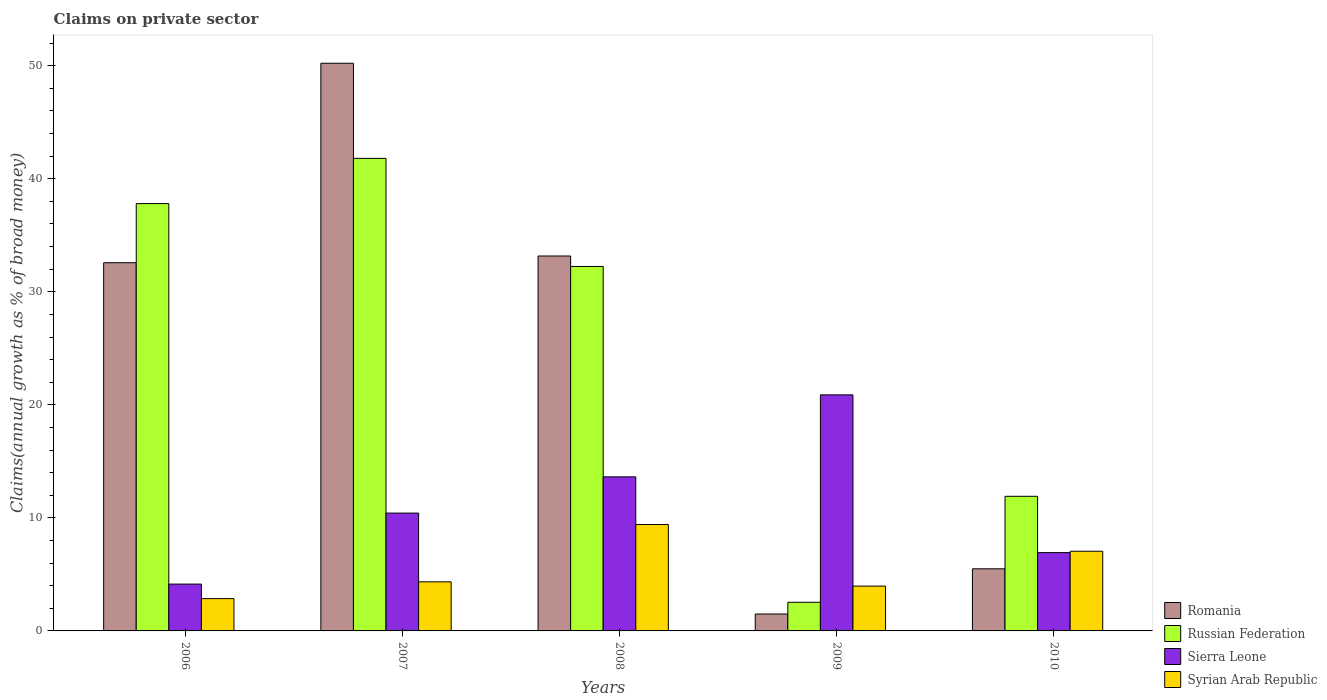How many different coloured bars are there?
Your answer should be compact. 4. How many bars are there on the 3rd tick from the left?
Provide a short and direct response. 4. What is the label of the 3rd group of bars from the left?
Your answer should be compact. 2008. In how many cases, is the number of bars for a given year not equal to the number of legend labels?
Ensure brevity in your answer.  0. What is the percentage of broad money claimed on private sector in Russian Federation in 2009?
Provide a short and direct response. 2.53. Across all years, what is the maximum percentage of broad money claimed on private sector in Sierra Leone?
Make the answer very short. 20.88. Across all years, what is the minimum percentage of broad money claimed on private sector in Sierra Leone?
Make the answer very short. 4.14. What is the total percentage of broad money claimed on private sector in Russian Federation in the graph?
Make the answer very short. 126.29. What is the difference between the percentage of broad money claimed on private sector in Syrian Arab Republic in 2007 and that in 2008?
Your answer should be compact. -5.07. What is the difference between the percentage of broad money claimed on private sector in Syrian Arab Republic in 2008 and the percentage of broad money claimed on private sector in Russian Federation in 2010?
Provide a short and direct response. -2.5. What is the average percentage of broad money claimed on private sector in Syrian Arab Republic per year?
Keep it short and to the point. 5.52. In the year 2007, what is the difference between the percentage of broad money claimed on private sector in Romania and percentage of broad money claimed on private sector in Syrian Arab Republic?
Make the answer very short. 45.88. In how many years, is the percentage of broad money claimed on private sector in Sierra Leone greater than 4 %?
Keep it short and to the point. 5. What is the ratio of the percentage of broad money claimed on private sector in Sierra Leone in 2008 to that in 2010?
Give a very brief answer. 1.97. Is the difference between the percentage of broad money claimed on private sector in Romania in 2008 and 2010 greater than the difference between the percentage of broad money claimed on private sector in Syrian Arab Republic in 2008 and 2010?
Make the answer very short. Yes. What is the difference between the highest and the second highest percentage of broad money claimed on private sector in Sierra Leone?
Your answer should be compact. 7.25. What is the difference between the highest and the lowest percentage of broad money claimed on private sector in Russian Federation?
Make the answer very short. 39.27. In how many years, is the percentage of broad money claimed on private sector in Russian Federation greater than the average percentage of broad money claimed on private sector in Russian Federation taken over all years?
Offer a terse response. 3. What does the 2nd bar from the left in 2006 represents?
Give a very brief answer. Russian Federation. What does the 2nd bar from the right in 2007 represents?
Your answer should be very brief. Sierra Leone. Is it the case that in every year, the sum of the percentage of broad money claimed on private sector in Sierra Leone and percentage of broad money claimed on private sector in Syrian Arab Republic is greater than the percentage of broad money claimed on private sector in Romania?
Give a very brief answer. No. Are all the bars in the graph horizontal?
Your answer should be compact. No. What is the difference between two consecutive major ticks on the Y-axis?
Keep it short and to the point. 10. How are the legend labels stacked?
Make the answer very short. Vertical. What is the title of the graph?
Ensure brevity in your answer.  Claims on private sector. Does "Hungary" appear as one of the legend labels in the graph?
Your response must be concise. No. What is the label or title of the X-axis?
Provide a short and direct response. Years. What is the label or title of the Y-axis?
Provide a succinct answer. Claims(annual growth as % of broad money). What is the Claims(annual growth as % of broad money) in Romania in 2006?
Make the answer very short. 32.57. What is the Claims(annual growth as % of broad money) of Russian Federation in 2006?
Provide a succinct answer. 37.8. What is the Claims(annual growth as % of broad money) in Sierra Leone in 2006?
Your answer should be very brief. 4.14. What is the Claims(annual growth as % of broad money) in Syrian Arab Republic in 2006?
Your answer should be very brief. 2.86. What is the Claims(annual growth as % of broad money) in Romania in 2007?
Provide a succinct answer. 50.22. What is the Claims(annual growth as % of broad money) of Russian Federation in 2007?
Ensure brevity in your answer.  41.8. What is the Claims(annual growth as % of broad money) in Sierra Leone in 2007?
Offer a terse response. 10.42. What is the Claims(annual growth as % of broad money) in Syrian Arab Republic in 2007?
Your response must be concise. 4.34. What is the Claims(annual growth as % of broad money) in Romania in 2008?
Ensure brevity in your answer.  33.17. What is the Claims(annual growth as % of broad money) in Russian Federation in 2008?
Ensure brevity in your answer.  32.24. What is the Claims(annual growth as % of broad money) in Sierra Leone in 2008?
Your response must be concise. 13.63. What is the Claims(annual growth as % of broad money) of Syrian Arab Republic in 2008?
Your response must be concise. 9.41. What is the Claims(annual growth as % of broad money) in Romania in 2009?
Your response must be concise. 1.5. What is the Claims(annual growth as % of broad money) of Russian Federation in 2009?
Ensure brevity in your answer.  2.53. What is the Claims(annual growth as % of broad money) in Sierra Leone in 2009?
Your answer should be compact. 20.88. What is the Claims(annual growth as % of broad money) in Syrian Arab Republic in 2009?
Give a very brief answer. 3.96. What is the Claims(annual growth as % of broad money) in Romania in 2010?
Your response must be concise. 5.49. What is the Claims(annual growth as % of broad money) in Russian Federation in 2010?
Offer a terse response. 11.91. What is the Claims(annual growth as % of broad money) of Sierra Leone in 2010?
Your response must be concise. 6.93. What is the Claims(annual growth as % of broad money) of Syrian Arab Republic in 2010?
Offer a very short reply. 7.05. Across all years, what is the maximum Claims(annual growth as % of broad money) of Romania?
Keep it short and to the point. 50.22. Across all years, what is the maximum Claims(annual growth as % of broad money) of Russian Federation?
Give a very brief answer. 41.8. Across all years, what is the maximum Claims(annual growth as % of broad money) in Sierra Leone?
Provide a succinct answer. 20.88. Across all years, what is the maximum Claims(annual growth as % of broad money) in Syrian Arab Republic?
Provide a succinct answer. 9.41. Across all years, what is the minimum Claims(annual growth as % of broad money) in Romania?
Offer a terse response. 1.5. Across all years, what is the minimum Claims(annual growth as % of broad money) in Russian Federation?
Give a very brief answer. 2.53. Across all years, what is the minimum Claims(annual growth as % of broad money) of Sierra Leone?
Your response must be concise. 4.14. Across all years, what is the minimum Claims(annual growth as % of broad money) of Syrian Arab Republic?
Ensure brevity in your answer.  2.86. What is the total Claims(annual growth as % of broad money) of Romania in the graph?
Your answer should be compact. 122.95. What is the total Claims(annual growth as % of broad money) of Russian Federation in the graph?
Give a very brief answer. 126.29. What is the total Claims(annual growth as % of broad money) of Sierra Leone in the graph?
Give a very brief answer. 56.01. What is the total Claims(annual growth as % of broad money) of Syrian Arab Republic in the graph?
Ensure brevity in your answer.  27.62. What is the difference between the Claims(annual growth as % of broad money) in Romania in 2006 and that in 2007?
Your response must be concise. -17.65. What is the difference between the Claims(annual growth as % of broad money) in Russian Federation in 2006 and that in 2007?
Give a very brief answer. -4. What is the difference between the Claims(annual growth as % of broad money) in Sierra Leone in 2006 and that in 2007?
Your answer should be compact. -6.28. What is the difference between the Claims(annual growth as % of broad money) in Syrian Arab Republic in 2006 and that in 2007?
Offer a very short reply. -1.48. What is the difference between the Claims(annual growth as % of broad money) in Romania in 2006 and that in 2008?
Your answer should be compact. -0.6. What is the difference between the Claims(annual growth as % of broad money) of Russian Federation in 2006 and that in 2008?
Your answer should be very brief. 5.56. What is the difference between the Claims(annual growth as % of broad money) in Sierra Leone in 2006 and that in 2008?
Offer a terse response. -9.49. What is the difference between the Claims(annual growth as % of broad money) of Syrian Arab Republic in 2006 and that in 2008?
Ensure brevity in your answer.  -6.55. What is the difference between the Claims(annual growth as % of broad money) of Romania in 2006 and that in 2009?
Ensure brevity in your answer.  31.08. What is the difference between the Claims(annual growth as % of broad money) of Russian Federation in 2006 and that in 2009?
Ensure brevity in your answer.  35.27. What is the difference between the Claims(annual growth as % of broad money) in Sierra Leone in 2006 and that in 2009?
Provide a short and direct response. -16.74. What is the difference between the Claims(annual growth as % of broad money) of Syrian Arab Republic in 2006 and that in 2009?
Ensure brevity in your answer.  -1.11. What is the difference between the Claims(annual growth as % of broad money) of Romania in 2006 and that in 2010?
Your answer should be compact. 27.08. What is the difference between the Claims(annual growth as % of broad money) of Russian Federation in 2006 and that in 2010?
Offer a very short reply. 25.89. What is the difference between the Claims(annual growth as % of broad money) of Sierra Leone in 2006 and that in 2010?
Make the answer very short. -2.78. What is the difference between the Claims(annual growth as % of broad money) of Syrian Arab Republic in 2006 and that in 2010?
Offer a very short reply. -4.19. What is the difference between the Claims(annual growth as % of broad money) in Romania in 2007 and that in 2008?
Your response must be concise. 17.05. What is the difference between the Claims(annual growth as % of broad money) in Russian Federation in 2007 and that in 2008?
Make the answer very short. 9.56. What is the difference between the Claims(annual growth as % of broad money) in Sierra Leone in 2007 and that in 2008?
Keep it short and to the point. -3.21. What is the difference between the Claims(annual growth as % of broad money) of Syrian Arab Republic in 2007 and that in 2008?
Your answer should be compact. -5.07. What is the difference between the Claims(annual growth as % of broad money) of Romania in 2007 and that in 2009?
Give a very brief answer. 48.72. What is the difference between the Claims(annual growth as % of broad money) of Russian Federation in 2007 and that in 2009?
Ensure brevity in your answer.  39.27. What is the difference between the Claims(annual growth as % of broad money) in Sierra Leone in 2007 and that in 2009?
Provide a short and direct response. -10.46. What is the difference between the Claims(annual growth as % of broad money) of Syrian Arab Republic in 2007 and that in 2009?
Your answer should be compact. 0.38. What is the difference between the Claims(annual growth as % of broad money) in Romania in 2007 and that in 2010?
Provide a short and direct response. 44.72. What is the difference between the Claims(annual growth as % of broad money) in Russian Federation in 2007 and that in 2010?
Ensure brevity in your answer.  29.89. What is the difference between the Claims(annual growth as % of broad money) in Sierra Leone in 2007 and that in 2010?
Your response must be concise. 3.5. What is the difference between the Claims(annual growth as % of broad money) in Syrian Arab Republic in 2007 and that in 2010?
Your response must be concise. -2.71. What is the difference between the Claims(annual growth as % of broad money) in Romania in 2008 and that in 2009?
Offer a terse response. 31.67. What is the difference between the Claims(annual growth as % of broad money) in Russian Federation in 2008 and that in 2009?
Give a very brief answer. 29.71. What is the difference between the Claims(annual growth as % of broad money) of Sierra Leone in 2008 and that in 2009?
Give a very brief answer. -7.25. What is the difference between the Claims(annual growth as % of broad money) of Syrian Arab Republic in 2008 and that in 2009?
Keep it short and to the point. 5.45. What is the difference between the Claims(annual growth as % of broad money) of Romania in 2008 and that in 2010?
Provide a succinct answer. 27.67. What is the difference between the Claims(annual growth as % of broad money) in Russian Federation in 2008 and that in 2010?
Your answer should be very brief. 20.33. What is the difference between the Claims(annual growth as % of broad money) of Sierra Leone in 2008 and that in 2010?
Provide a short and direct response. 6.7. What is the difference between the Claims(annual growth as % of broad money) in Syrian Arab Republic in 2008 and that in 2010?
Provide a succinct answer. 2.36. What is the difference between the Claims(annual growth as % of broad money) of Romania in 2009 and that in 2010?
Offer a terse response. -4. What is the difference between the Claims(annual growth as % of broad money) of Russian Federation in 2009 and that in 2010?
Your answer should be very brief. -9.38. What is the difference between the Claims(annual growth as % of broad money) in Sierra Leone in 2009 and that in 2010?
Your answer should be very brief. 13.96. What is the difference between the Claims(annual growth as % of broad money) of Syrian Arab Republic in 2009 and that in 2010?
Make the answer very short. -3.08. What is the difference between the Claims(annual growth as % of broad money) in Romania in 2006 and the Claims(annual growth as % of broad money) in Russian Federation in 2007?
Your answer should be compact. -9.23. What is the difference between the Claims(annual growth as % of broad money) of Romania in 2006 and the Claims(annual growth as % of broad money) of Sierra Leone in 2007?
Make the answer very short. 22.15. What is the difference between the Claims(annual growth as % of broad money) of Romania in 2006 and the Claims(annual growth as % of broad money) of Syrian Arab Republic in 2007?
Make the answer very short. 28.23. What is the difference between the Claims(annual growth as % of broad money) of Russian Federation in 2006 and the Claims(annual growth as % of broad money) of Sierra Leone in 2007?
Make the answer very short. 27.38. What is the difference between the Claims(annual growth as % of broad money) in Russian Federation in 2006 and the Claims(annual growth as % of broad money) in Syrian Arab Republic in 2007?
Your response must be concise. 33.46. What is the difference between the Claims(annual growth as % of broad money) of Sierra Leone in 2006 and the Claims(annual growth as % of broad money) of Syrian Arab Republic in 2007?
Offer a terse response. -0.2. What is the difference between the Claims(annual growth as % of broad money) in Romania in 2006 and the Claims(annual growth as % of broad money) in Russian Federation in 2008?
Offer a terse response. 0.33. What is the difference between the Claims(annual growth as % of broad money) in Romania in 2006 and the Claims(annual growth as % of broad money) in Sierra Leone in 2008?
Offer a terse response. 18.94. What is the difference between the Claims(annual growth as % of broad money) of Romania in 2006 and the Claims(annual growth as % of broad money) of Syrian Arab Republic in 2008?
Offer a terse response. 23.16. What is the difference between the Claims(annual growth as % of broad money) in Russian Federation in 2006 and the Claims(annual growth as % of broad money) in Sierra Leone in 2008?
Keep it short and to the point. 24.17. What is the difference between the Claims(annual growth as % of broad money) of Russian Federation in 2006 and the Claims(annual growth as % of broad money) of Syrian Arab Republic in 2008?
Give a very brief answer. 28.39. What is the difference between the Claims(annual growth as % of broad money) of Sierra Leone in 2006 and the Claims(annual growth as % of broad money) of Syrian Arab Republic in 2008?
Give a very brief answer. -5.27. What is the difference between the Claims(annual growth as % of broad money) of Romania in 2006 and the Claims(annual growth as % of broad money) of Russian Federation in 2009?
Your response must be concise. 30.04. What is the difference between the Claims(annual growth as % of broad money) of Romania in 2006 and the Claims(annual growth as % of broad money) of Sierra Leone in 2009?
Your answer should be compact. 11.69. What is the difference between the Claims(annual growth as % of broad money) in Romania in 2006 and the Claims(annual growth as % of broad money) in Syrian Arab Republic in 2009?
Your answer should be compact. 28.61. What is the difference between the Claims(annual growth as % of broad money) of Russian Federation in 2006 and the Claims(annual growth as % of broad money) of Sierra Leone in 2009?
Provide a short and direct response. 16.92. What is the difference between the Claims(annual growth as % of broad money) in Russian Federation in 2006 and the Claims(annual growth as % of broad money) in Syrian Arab Republic in 2009?
Offer a terse response. 33.84. What is the difference between the Claims(annual growth as % of broad money) of Sierra Leone in 2006 and the Claims(annual growth as % of broad money) of Syrian Arab Republic in 2009?
Your response must be concise. 0.18. What is the difference between the Claims(annual growth as % of broad money) in Romania in 2006 and the Claims(annual growth as % of broad money) in Russian Federation in 2010?
Keep it short and to the point. 20.66. What is the difference between the Claims(annual growth as % of broad money) in Romania in 2006 and the Claims(annual growth as % of broad money) in Sierra Leone in 2010?
Provide a short and direct response. 25.64. What is the difference between the Claims(annual growth as % of broad money) in Romania in 2006 and the Claims(annual growth as % of broad money) in Syrian Arab Republic in 2010?
Provide a succinct answer. 25.52. What is the difference between the Claims(annual growth as % of broad money) of Russian Federation in 2006 and the Claims(annual growth as % of broad money) of Sierra Leone in 2010?
Make the answer very short. 30.88. What is the difference between the Claims(annual growth as % of broad money) of Russian Federation in 2006 and the Claims(annual growth as % of broad money) of Syrian Arab Republic in 2010?
Make the answer very short. 30.75. What is the difference between the Claims(annual growth as % of broad money) of Sierra Leone in 2006 and the Claims(annual growth as % of broad money) of Syrian Arab Republic in 2010?
Provide a succinct answer. -2.9. What is the difference between the Claims(annual growth as % of broad money) in Romania in 2007 and the Claims(annual growth as % of broad money) in Russian Federation in 2008?
Offer a very short reply. 17.98. What is the difference between the Claims(annual growth as % of broad money) in Romania in 2007 and the Claims(annual growth as % of broad money) in Sierra Leone in 2008?
Provide a succinct answer. 36.59. What is the difference between the Claims(annual growth as % of broad money) of Romania in 2007 and the Claims(annual growth as % of broad money) of Syrian Arab Republic in 2008?
Your answer should be very brief. 40.81. What is the difference between the Claims(annual growth as % of broad money) in Russian Federation in 2007 and the Claims(annual growth as % of broad money) in Sierra Leone in 2008?
Your answer should be compact. 28.17. What is the difference between the Claims(annual growth as % of broad money) in Russian Federation in 2007 and the Claims(annual growth as % of broad money) in Syrian Arab Republic in 2008?
Ensure brevity in your answer.  32.39. What is the difference between the Claims(annual growth as % of broad money) of Sierra Leone in 2007 and the Claims(annual growth as % of broad money) of Syrian Arab Republic in 2008?
Give a very brief answer. 1.01. What is the difference between the Claims(annual growth as % of broad money) in Romania in 2007 and the Claims(annual growth as % of broad money) in Russian Federation in 2009?
Your answer should be compact. 47.69. What is the difference between the Claims(annual growth as % of broad money) in Romania in 2007 and the Claims(annual growth as % of broad money) in Sierra Leone in 2009?
Provide a short and direct response. 29.33. What is the difference between the Claims(annual growth as % of broad money) of Romania in 2007 and the Claims(annual growth as % of broad money) of Syrian Arab Republic in 2009?
Your answer should be compact. 46.25. What is the difference between the Claims(annual growth as % of broad money) of Russian Federation in 2007 and the Claims(annual growth as % of broad money) of Sierra Leone in 2009?
Provide a short and direct response. 20.92. What is the difference between the Claims(annual growth as % of broad money) in Russian Federation in 2007 and the Claims(annual growth as % of broad money) in Syrian Arab Republic in 2009?
Your answer should be very brief. 37.84. What is the difference between the Claims(annual growth as % of broad money) of Sierra Leone in 2007 and the Claims(annual growth as % of broad money) of Syrian Arab Republic in 2009?
Give a very brief answer. 6.46. What is the difference between the Claims(annual growth as % of broad money) in Romania in 2007 and the Claims(annual growth as % of broad money) in Russian Federation in 2010?
Your response must be concise. 38.31. What is the difference between the Claims(annual growth as % of broad money) in Romania in 2007 and the Claims(annual growth as % of broad money) in Sierra Leone in 2010?
Make the answer very short. 43.29. What is the difference between the Claims(annual growth as % of broad money) in Romania in 2007 and the Claims(annual growth as % of broad money) in Syrian Arab Republic in 2010?
Ensure brevity in your answer.  43.17. What is the difference between the Claims(annual growth as % of broad money) in Russian Federation in 2007 and the Claims(annual growth as % of broad money) in Sierra Leone in 2010?
Keep it short and to the point. 34.88. What is the difference between the Claims(annual growth as % of broad money) in Russian Federation in 2007 and the Claims(annual growth as % of broad money) in Syrian Arab Republic in 2010?
Ensure brevity in your answer.  34.76. What is the difference between the Claims(annual growth as % of broad money) of Sierra Leone in 2007 and the Claims(annual growth as % of broad money) of Syrian Arab Republic in 2010?
Offer a very short reply. 3.38. What is the difference between the Claims(annual growth as % of broad money) in Romania in 2008 and the Claims(annual growth as % of broad money) in Russian Federation in 2009?
Provide a short and direct response. 30.64. What is the difference between the Claims(annual growth as % of broad money) in Romania in 2008 and the Claims(annual growth as % of broad money) in Sierra Leone in 2009?
Your answer should be very brief. 12.28. What is the difference between the Claims(annual growth as % of broad money) of Romania in 2008 and the Claims(annual growth as % of broad money) of Syrian Arab Republic in 2009?
Your answer should be compact. 29.2. What is the difference between the Claims(annual growth as % of broad money) of Russian Federation in 2008 and the Claims(annual growth as % of broad money) of Sierra Leone in 2009?
Keep it short and to the point. 11.36. What is the difference between the Claims(annual growth as % of broad money) of Russian Federation in 2008 and the Claims(annual growth as % of broad money) of Syrian Arab Republic in 2009?
Offer a very short reply. 28.28. What is the difference between the Claims(annual growth as % of broad money) of Sierra Leone in 2008 and the Claims(annual growth as % of broad money) of Syrian Arab Republic in 2009?
Keep it short and to the point. 9.67. What is the difference between the Claims(annual growth as % of broad money) of Romania in 2008 and the Claims(annual growth as % of broad money) of Russian Federation in 2010?
Provide a short and direct response. 21.26. What is the difference between the Claims(annual growth as % of broad money) of Romania in 2008 and the Claims(annual growth as % of broad money) of Sierra Leone in 2010?
Make the answer very short. 26.24. What is the difference between the Claims(annual growth as % of broad money) in Romania in 2008 and the Claims(annual growth as % of broad money) in Syrian Arab Republic in 2010?
Provide a short and direct response. 26.12. What is the difference between the Claims(annual growth as % of broad money) in Russian Federation in 2008 and the Claims(annual growth as % of broad money) in Sierra Leone in 2010?
Make the answer very short. 25.31. What is the difference between the Claims(annual growth as % of broad money) in Russian Federation in 2008 and the Claims(annual growth as % of broad money) in Syrian Arab Republic in 2010?
Make the answer very short. 25.19. What is the difference between the Claims(annual growth as % of broad money) of Sierra Leone in 2008 and the Claims(annual growth as % of broad money) of Syrian Arab Republic in 2010?
Your response must be concise. 6.58. What is the difference between the Claims(annual growth as % of broad money) in Romania in 2009 and the Claims(annual growth as % of broad money) in Russian Federation in 2010?
Provide a short and direct response. -10.41. What is the difference between the Claims(annual growth as % of broad money) in Romania in 2009 and the Claims(annual growth as % of broad money) in Sierra Leone in 2010?
Give a very brief answer. -5.43. What is the difference between the Claims(annual growth as % of broad money) of Romania in 2009 and the Claims(annual growth as % of broad money) of Syrian Arab Republic in 2010?
Keep it short and to the point. -5.55. What is the difference between the Claims(annual growth as % of broad money) of Russian Federation in 2009 and the Claims(annual growth as % of broad money) of Sierra Leone in 2010?
Provide a short and direct response. -4.39. What is the difference between the Claims(annual growth as % of broad money) in Russian Federation in 2009 and the Claims(annual growth as % of broad money) in Syrian Arab Republic in 2010?
Your answer should be very brief. -4.52. What is the difference between the Claims(annual growth as % of broad money) of Sierra Leone in 2009 and the Claims(annual growth as % of broad money) of Syrian Arab Republic in 2010?
Offer a terse response. 13.84. What is the average Claims(annual growth as % of broad money) of Romania per year?
Your answer should be compact. 24.59. What is the average Claims(annual growth as % of broad money) of Russian Federation per year?
Keep it short and to the point. 25.26. What is the average Claims(annual growth as % of broad money) of Sierra Leone per year?
Give a very brief answer. 11.2. What is the average Claims(annual growth as % of broad money) of Syrian Arab Republic per year?
Offer a very short reply. 5.52. In the year 2006, what is the difference between the Claims(annual growth as % of broad money) in Romania and Claims(annual growth as % of broad money) in Russian Federation?
Provide a succinct answer. -5.23. In the year 2006, what is the difference between the Claims(annual growth as % of broad money) in Romania and Claims(annual growth as % of broad money) in Sierra Leone?
Offer a terse response. 28.43. In the year 2006, what is the difference between the Claims(annual growth as % of broad money) in Romania and Claims(annual growth as % of broad money) in Syrian Arab Republic?
Offer a very short reply. 29.72. In the year 2006, what is the difference between the Claims(annual growth as % of broad money) in Russian Federation and Claims(annual growth as % of broad money) in Sierra Leone?
Make the answer very short. 33.66. In the year 2006, what is the difference between the Claims(annual growth as % of broad money) of Russian Federation and Claims(annual growth as % of broad money) of Syrian Arab Republic?
Your answer should be very brief. 34.95. In the year 2006, what is the difference between the Claims(annual growth as % of broad money) of Sierra Leone and Claims(annual growth as % of broad money) of Syrian Arab Republic?
Keep it short and to the point. 1.29. In the year 2007, what is the difference between the Claims(annual growth as % of broad money) of Romania and Claims(annual growth as % of broad money) of Russian Federation?
Ensure brevity in your answer.  8.42. In the year 2007, what is the difference between the Claims(annual growth as % of broad money) in Romania and Claims(annual growth as % of broad money) in Sierra Leone?
Provide a short and direct response. 39.8. In the year 2007, what is the difference between the Claims(annual growth as % of broad money) in Romania and Claims(annual growth as % of broad money) in Syrian Arab Republic?
Your response must be concise. 45.88. In the year 2007, what is the difference between the Claims(annual growth as % of broad money) of Russian Federation and Claims(annual growth as % of broad money) of Sierra Leone?
Ensure brevity in your answer.  31.38. In the year 2007, what is the difference between the Claims(annual growth as % of broad money) of Russian Federation and Claims(annual growth as % of broad money) of Syrian Arab Republic?
Give a very brief answer. 37.46. In the year 2007, what is the difference between the Claims(annual growth as % of broad money) of Sierra Leone and Claims(annual growth as % of broad money) of Syrian Arab Republic?
Keep it short and to the point. 6.08. In the year 2008, what is the difference between the Claims(annual growth as % of broad money) in Romania and Claims(annual growth as % of broad money) in Russian Federation?
Your response must be concise. 0.93. In the year 2008, what is the difference between the Claims(annual growth as % of broad money) in Romania and Claims(annual growth as % of broad money) in Sierra Leone?
Your response must be concise. 19.54. In the year 2008, what is the difference between the Claims(annual growth as % of broad money) in Romania and Claims(annual growth as % of broad money) in Syrian Arab Republic?
Make the answer very short. 23.76. In the year 2008, what is the difference between the Claims(annual growth as % of broad money) of Russian Federation and Claims(annual growth as % of broad money) of Sierra Leone?
Your answer should be very brief. 18.61. In the year 2008, what is the difference between the Claims(annual growth as % of broad money) of Russian Federation and Claims(annual growth as % of broad money) of Syrian Arab Republic?
Your answer should be compact. 22.83. In the year 2008, what is the difference between the Claims(annual growth as % of broad money) in Sierra Leone and Claims(annual growth as % of broad money) in Syrian Arab Republic?
Make the answer very short. 4.22. In the year 2009, what is the difference between the Claims(annual growth as % of broad money) in Romania and Claims(annual growth as % of broad money) in Russian Federation?
Offer a terse response. -1.04. In the year 2009, what is the difference between the Claims(annual growth as % of broad money) in Romania and Claims(annual growth as % of broad money) in Sierra Leone?
Provide a short and direct response. -19.39. In the year 2009, what is the difference between the Claims(annual growth as % of broad money) of Romania and Claims(annual growth as % of broad money) of Syrian Arab Republic?
Ensure brevity in your answer.  -2.47. In the year 2009, what is the difference between the Claims(annual growth as % of broad money) of Russian Federation and Claims(annual growth as % of broad money) of Sierra Leone?
Your answer should be very brief. -18.35. In the year 2009, what is the difference between the Claims(annual growth as % of broad money) of Russian Federation and Claims(annual growth as % of broad money) of Syrian Arab Republic?
Your answer should be compact. -1.43. In the year 2009, what is the difference between the Claims(annual growth as % of broad money) of Sierra Leone and Claims(annual growth as % of broad money) of Syrian Arab Republic?
Make the answer very short. 16.92. In the year 2010, what is the difference between the Claims(annual growth as % of broad money) in Romania and Claims(annual growth as % of broad money) in Russian Federation?
Provide a short and direct response. -6.41. In the year 2010, what is the difference between the Claims(annual growth as % of broad money) of Romania and Claims(annual growth as % of broad money) of Sierra Leone?
Your answer should be very brief. -1.43. In the year 2010, what is the difference between the Claims(annual growth as % of broad money) in Romania and Claims(annual growth as % of broad money) in Syrian Arab Republic?
Your response must be concise. -1.55. In the year 2010, what is the difference between the Claims(annual growth as % of broad money) in Russian Federation and Claims(annual growth as % of broad money) in Sierra Leone?
Give a very brief answer. 4.98. In the year 2010, what is the difference between the Claims(annual growth as % of broad money) of Russian Federation and Claims(annual growth as % of broad money) of Syrian Arab Republic?
Provide a succinct answer. 4.86. In the year 2010, what is the difference between the Claims(annual growth as % of broad money) in Sierra Leone and Claims(annual growth as % of broad money) in Syrian Arab Republic?
Provide a succinct answer. -0.12. What is the ratio of the Claims(annual growth as % of broad money) in Romania in 2006 to that in 2007?
Your answer should be very brief. 0.65. What is the ratio of the Claims(annual growth as % of broad money) in Russian Federation in 2006 to that in 2007?
Offer a very short reply. 0.9. What is the ratio of the Claims(annual growth as % of broad money) in Sierra Leone in 2006 to that in 2007?
Offer a terse response. 0.4. What is the ratio of the Claims(annual growth as % of broad money) of Syrian Arab Republic in 2006 to that in 2007?
Your answer should be compact. 0.66. What is the ratio of the Claims(annual growth as % of broad money) in Russian Federation in 2006 to that in 2008?
Ensure brevity in your answer.  1.17. What is the ratio of the Claims(annual growth as % of broad money) in Sierra Leone in 2006 to that in 2008?
Give a very brief answer. 0.3. What is the ratio of the Claims(annual growth as % of broad money) of Syrian Arab Republic in 2006 to that in 2008?
Keep it short and to the point. 0.3. What is the ratio of the Claims(annual growth as % of broad money) in Romania in 2006 to that in 2009?
Offer a terse response. 21.76. What is the ratio of the Claims(annual growth as % of broad money) in Russian Federation in 2006 to that in 2009?
Ensure brevity in your answer.  14.92. What is the ratio of the Claims(annual growth as % of broad money) of Sierra Leone in 2006 to that in 2009?
Your answer should be very brief. 0.2. What is the ratio of the Claims(annual growth as % of broad money) of Syrian Arab Republic in 2006 to that in 2009?
Give a very brief answer. 0.72. What is the ratio of the Claims(annual growth as % of broad money) in Romania in 2006 to that in 2010?
Offer a very short reply. 5.93. What is the ratio of the Claims(annual growth as % of broad money) in Russian Federation in 2006 to that in 2010?
Your answer should be very brief. 3.17. What is the ratio of the Claims(annual growth as % of broad money) of Sierra Leone in 2006 to that in 2010?
Your answer should be very brief. 0.6. What is the ratio of the Claims(annual growth as % of broad money) of Syrian Arab Republic in 2006 to that in 2010?
Offer a very short reply. 0.41. What is the ratio of the Claims(annual growth as % of broad money) in Romania in 2007 to that in 2008?
Offer a very short reply. 1.51. What is the ratio of the Claims(annual growth as % of broad money) of Russian Federation in 2007 to that in 2008?
Ensure brevity in your answer.  1.3. What is the ratio of the Claims(annual growth as % of broad money) of Sierra Leone in 2007 to that in 2008?
Ensure brevity in your answer.  0.76. What is the ratio of the Claims(annual growth as % of broad money) of Syrian Arab Republic in 2007 to that in 2008?
Ensure brevity in your answer.  0.46. What is the ratio of the Claims(annual growth as % of broad money) in Romania in 2007 to that in 2009?
Ensure brevity in your answer.  33.55. What is the ratio of the Claims(annual growth as % of broad money) of Russian Federation in 2007 to that in 2009?
Make the answer very short. 16.5. What is the ratio of the Claims(annual growth as % of broad money) in Sierra Leone in 2007 to that in 2009?
Provide a succinct answer. 0.5. What is the ratio of the Claims(annual growth as % of broad money) of Syrian Arab Republic in 2007 to that in 2009?
Your answer should be compact. 1.1. What is the ratio of the Claims(annual growth as % of broad money) in Romania in 2007 to that in 2010?
Provide a short and direct response. 9.14. What is the ratio of the Claims(annual growth as % of broad money) in Russian Federation in 2007 to that in 2010?
Provide a short and direct response. 3.51. What is the ratio of the Claims(annual growth as % of broad money) of Sierra Leone in 2007 to that in 2010?
Make the answer very short. 1.5. What is the ratio of the Claims(annual growth as % of broad money) of Syrian Arab Republic in 2007 to that in 2010?
Your response must be concise. 0.62. What is the ratio of the Claims(annual growth as % of broad money) in Romania in 2008 to that in 2009?
Offer a terse response. 22.16. What is the ratio of the Claims(annual growth as % of broad money) of Russian Federation in 2008 to that in 2009?
Offer a very short reply. 12.73. What is the ratio of the Claims(annual growth as % of broad money) of Sierra Leone in 2008 to that in 2009?
Make the answer very short. 0.65. What is the ratio of the Claims(annual growth as % of broad money) of Syrian Arab Republic in 2008 to that in 2009?
Make the answer very short. 2.37. What is the ratio of the Claims(annual growth as % of broad money) of Romania in 2008 to that in 2010?
Give a very brief answer. 6.04. What is the ratio of the Claims(annual growth as % of broad money) in Russian Federation in 2008 to that in 2010?
Provide a succinct answer. 2.71. What is the ratio of the Claims(annual growth as % of broad money) of Sierra Leone in 2008 to that in 2010?
Give a very brief answer. 1.97. What is the ratio of the Claims(annual growth as % of broad money) of Syrian Arab Republic in 2008 to that in 2010?
Ensure brevity in your answer.  1.34. What is the ratio of the Claims(annual growth as % of broad money) in Romania in 2009 to that in 2010?
Your response must be concise. 0.27. What is the ratio of the Claims(annual growth as % of broad money) of Russian Federation in 2009 to that in 2010?
Ensure brevity in your answer.  0.21. What is the ratio of the Claims(annual growth as % of broad money) of Sierra Leone in 2009 to that in 2010?
Provide a short and direct response. 3.01. What is the ratio of the Claims(annual growth as % of broad money) in Syrian Arab Republic in 2009 to that in 2010?
Your response must be concise. 0.56. What is the difference between the highest and the second highest Claims(annual growth as % of broad money) in Romania?
Your answer should be very brief. 17.05. What is the difference between the highest and the second highest Claims(annual growth as % of broad money) of Russian Federation?
Keep it short and to the point. 4. What is the difference between the highest and the second highest Claims(annual growth as % of broad money) in Sierra Leone?
Your response must be concise. 7.25. What is the difference between the highest and the second highest Claims(annual growth as % of broad money) in Syrian Arab Republic?
Your response must be concise. 2.36. What is the difference between the highest and the lowest Claims(annual growth as % of broad money) of Romania?
Make the answer very short. 48.72. What is the difference between the highest and the lowest Claims(annual growth as % of broad money) of Russian Federation?
Provide a short and direct response. 39.27. What is the difference between the highest and the lowest Claims(annual growth as % of broad money) in Sierra Leone?
Your response must be concise. 16.74. What is the difference between the highest and the lowest Claims(annual growth as % of broad money) of Syrian Arab Republic?
Provide a succinct answer. 6.55. 